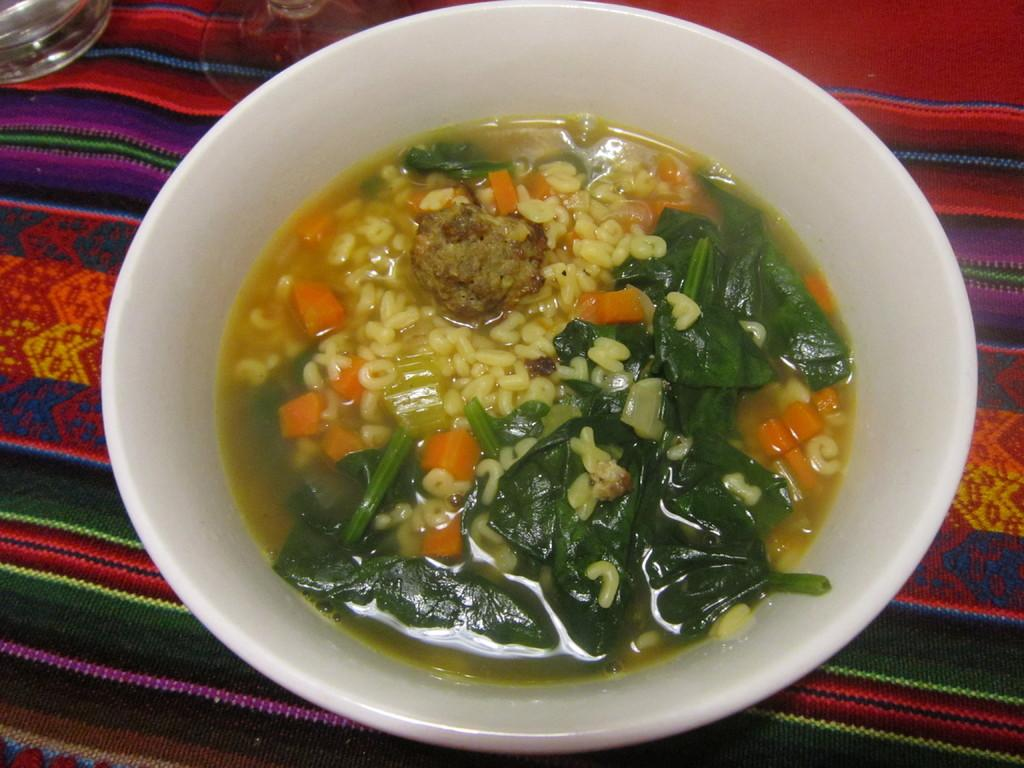What is the main object in the image? There is a cup in the image. What is inside the cup? The cup contains another cup. What other object is visible in the image? There is a glass in the image. How is the glass positioned in the image? The glass is on a mat. What type of spark can be seen coming from the cup in the image? There is no spark present in the image; it only features a cup containing another cup and a glass on a mat. 